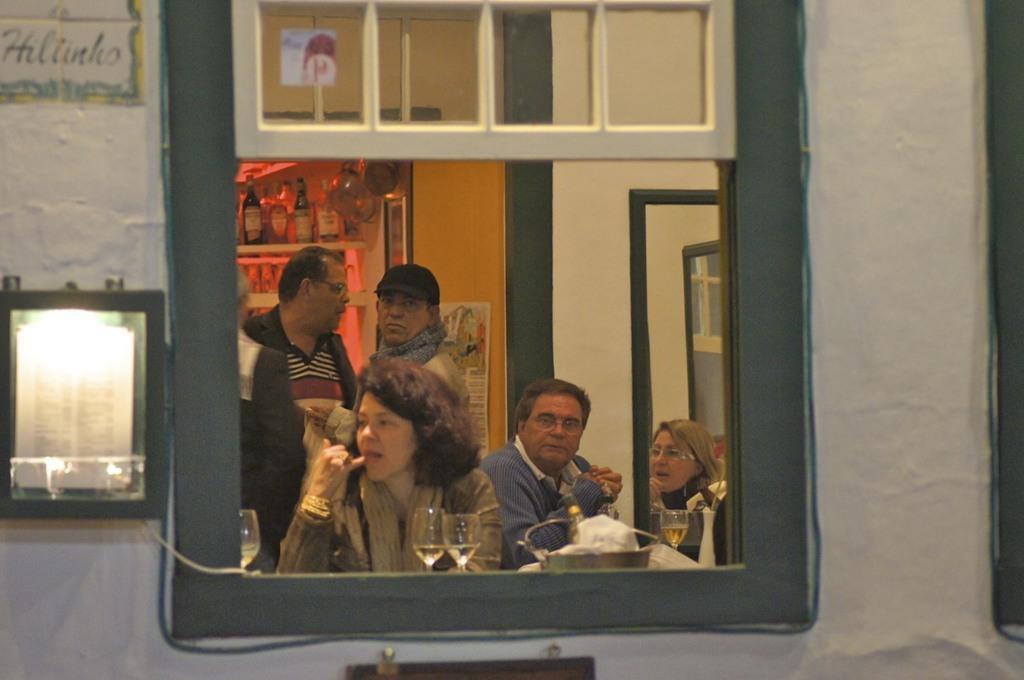Can you describe this image briefly? In this picture I can see the wall in front, on which there is a window and on the left side of this image I can see the light. through the window I can see 2 men and 2 women and I can see few glasses. In the background I can see the wall and few bottles on the racks. On the top left of this picture I can see a word written. 